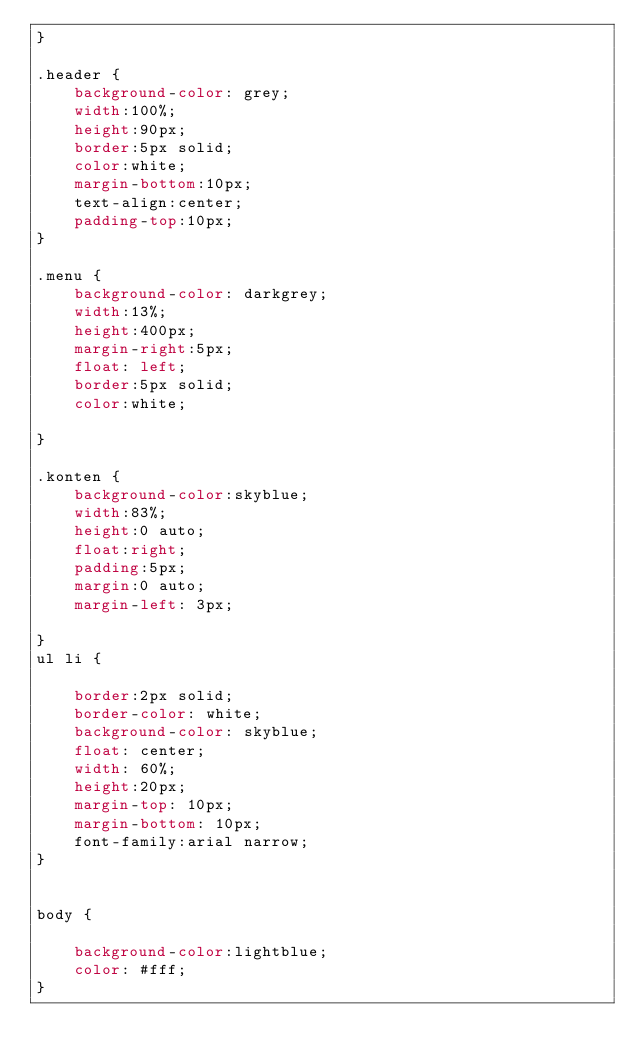<code> <loc_0><loc_0><loc_500><loc_500><_CSS_>}
	
.header {
	background-color: grey;
	width:100%;
	height:90px;
	border:5px solid;
	color:white;
	margin-bottom:10px;
	text-align:center;
	padding-top:10px; 
}

.menu {
	background-color: darkgrey;
	width:13%;
	height:400px;
	margin-right:5px;
	float: left;
	border:5px solid;
	color:white;

}

.konten {
	background-color:skyblue;
	width:83%;
	height:0 auto;
	float:right;
	padding:5px;
	margin:0 auto;
	margin-left: 3px;

}
ul li {

	border:2px solid;
	border-color: white;
	background-color: skyblue;
	float: center;
	width: 60%;
	height:20px;
	margin-top: 10px;
	margin-bottom: 10px;
	font-family:arial narrow;
}


body {

	background-color:lightblue;
	color: #fff;
}
</code> 